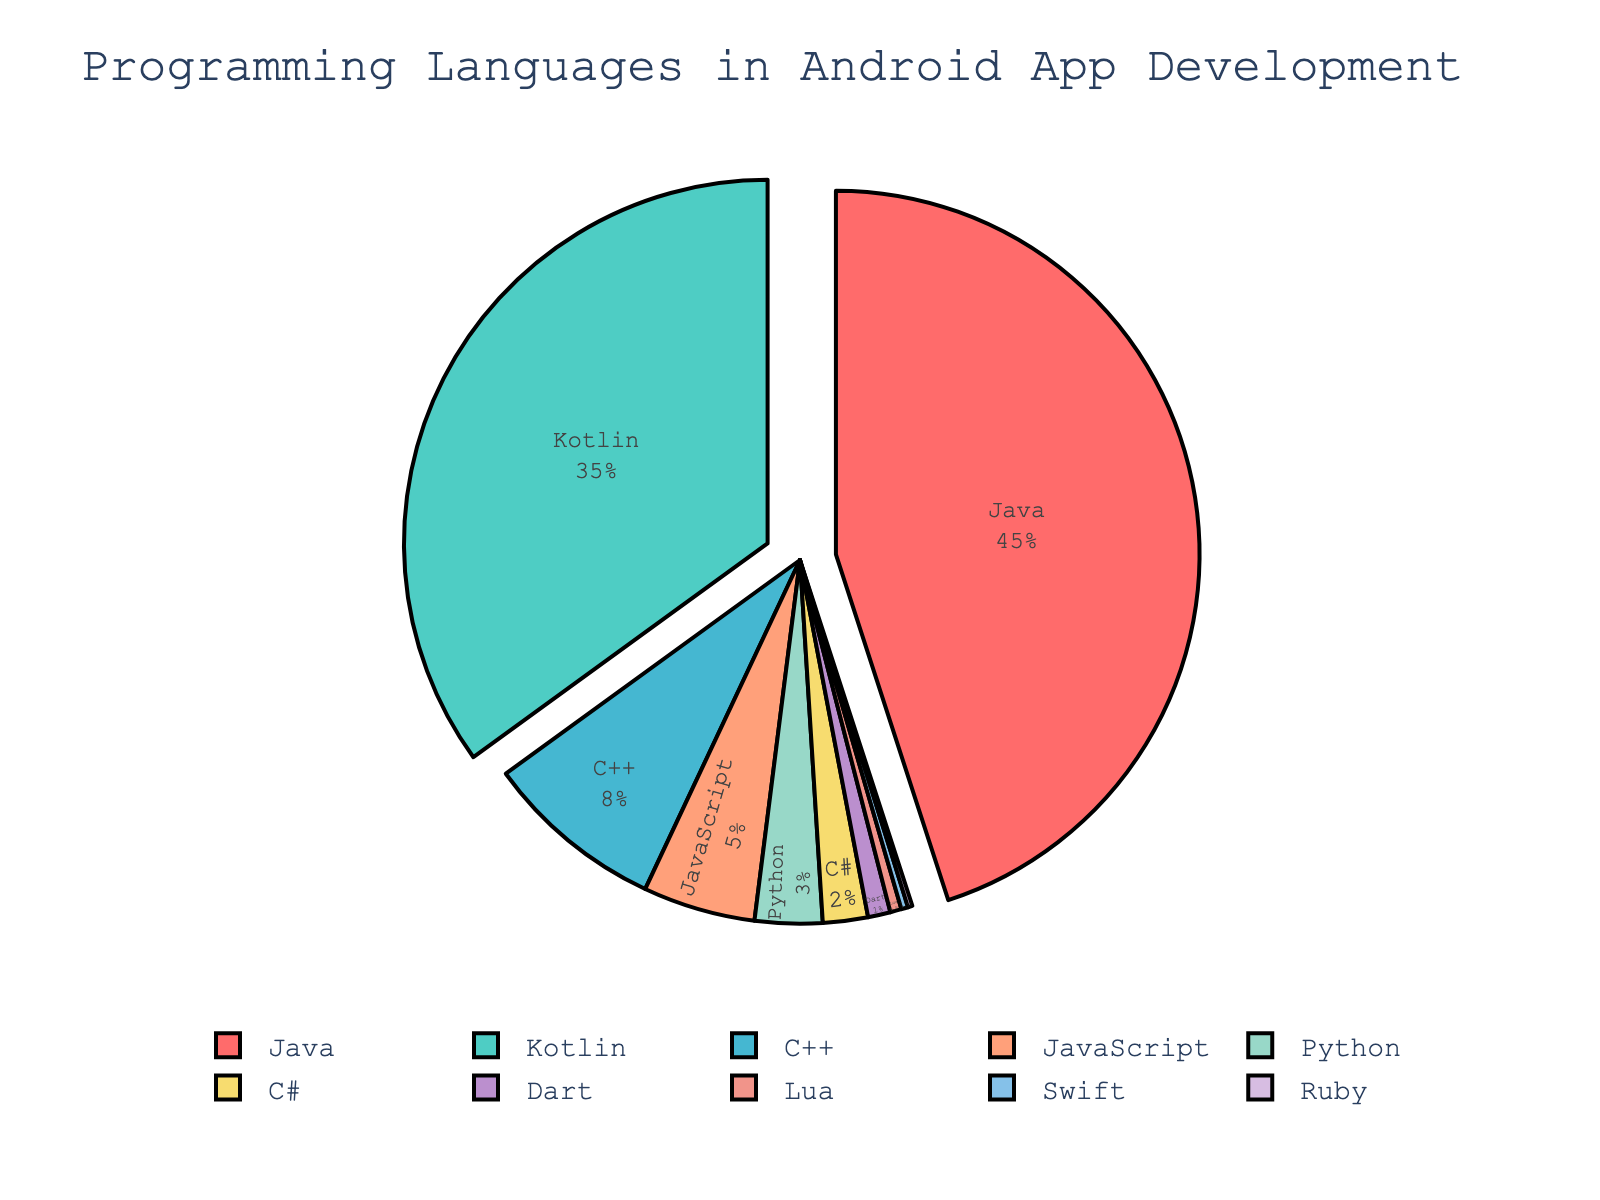What percentage of Android app development is done using Kotlin? Locate the section representing "Kotlin" in the pie chart and read the percentage value labeled.
Answer: 35% What is the combined percentage of Java and C++ usage in Android app development? Find the percentages for Java and C++ in the pie chart, then sum them up: 45% (Java) + 8% (C++) = 53%.
Answer: 53% Which language has the lowest usage in Android app development? Identify the slice with the smallest percentage in the chart, which is "Ruby" with 0.2%.
Answer: Ruby How much more is Java used compared to Kotlin for Android app development? Subtract the percentage of Kotlin from the percentage of Java: 45% (Java) - 35% (Kotlin) = 10%.
Answer: 10% What percentage of Android app development is done using Java, Kotlin, and C++ combined? Add together the individual percentages of Java, Kotlin, and C++: 45% (Java) + 35% (Kotlin) + 8% (C++) = 88%.
Answer: 88% How does the usage of JavaScript compare to Python in Android app development? Find the percentages for JavaScript and Python, then compare: JavaScript (5%) is greater than Python (3%).
Answer: JavaScript > Python Which two non-primary languages (excluding Java and Kotlin) have the closest usage percentages? Compare the other languages' percentages and find the closest pair: Python (3%) and C# (2%) have the smallest difference of 1%.
Answer: Python and C# Is C++ used more or less than JavaScript in Android app development? Compare the percentage values of C++ and JavaScript: C++ (8%) is greater than JavaScript (5%).
Answer: More What is the total percentage of Android app development done using languages other than Java and Kotlin? Sum all the percentages excluding Java and Kotlin: 8% (C++) + 5% (JavaScript) + 3% (Python) + 2% (C#) + 1% (Dart) + 0.5% (Lua) + 0.3% (Swift) + 0.2% (Ruby) = 20%.
Answer: 20% Are there any languages used less than 1% in Android app development? If so, name them. Identify any segments with less than 1% usage in the pie chart: Dart (1%), Lua (0.5%), Swift (0.3%), and Ruby (0.2%).
Answer: Dart, Lua, Swift, Ruby 